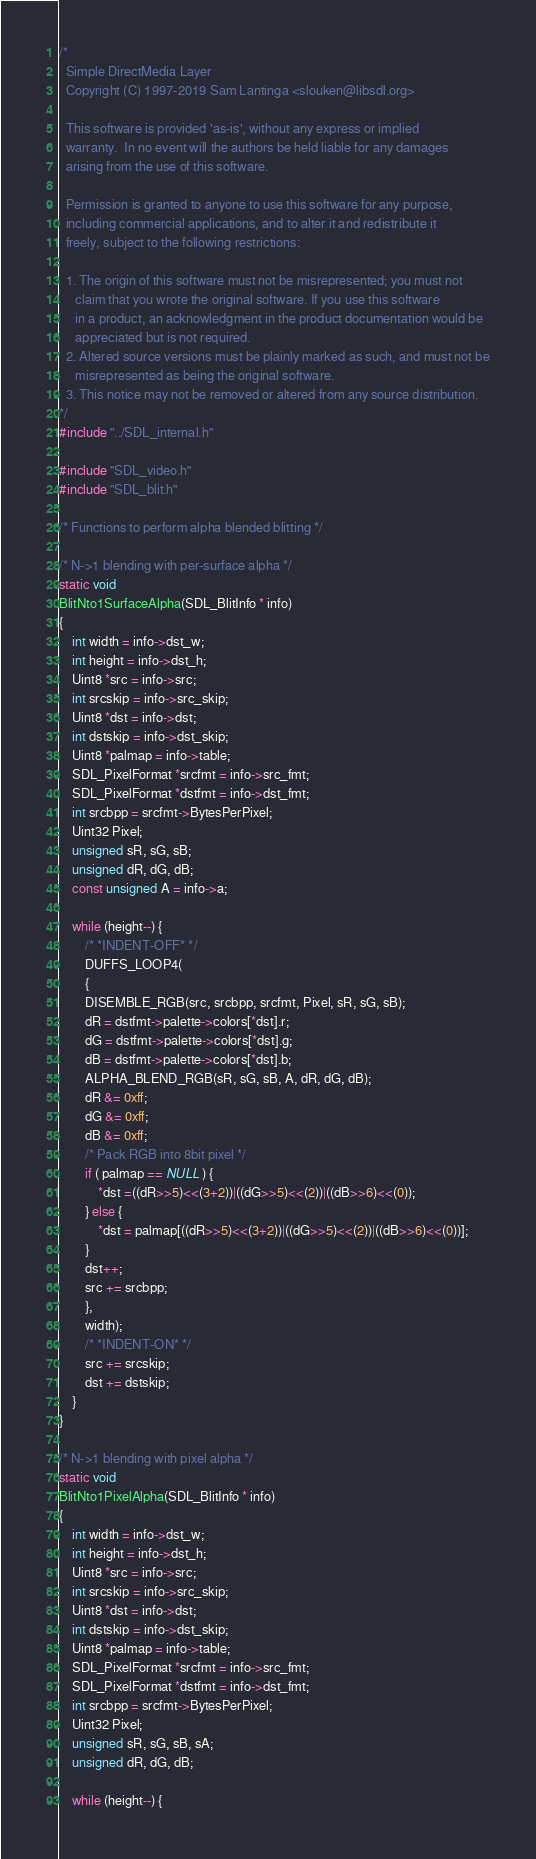Convert code to text. <code><loc_0><loc_0><loc_500><loc_500><_C_>/*
  Simple DirectMedia Layer
  Copyright (C) 1997-2019 Sam Lantinga <slouken@libsdl.org>

  This software is provided 'as-is', without any express or implied
  warranty.  In no event will the authors be held liable for any damages
  arising from the use of this software.

  Permission is granted to anyone to use this software for any purpose,
  including commercial applications, and to alter it and redistribute it
  freely, subject to the following restrictions:

  1. The origin of this software must not be misrepresented; you must not
     claim that you wrote the original software. If you use this software
     in a product, an acknowledgment in the product documentation would be
     appreciated but is not required.
  2. Altered source versions must be plainly marked as such, and must not be
     misrepresented as being the original software.
  3. This notice may not be removed or altered from any source distribution.
*/
#include "../SDL_internal.h"

#include "SDL_video.h"
#include "SDL_blit.h"

/* Functions to perform alpha blended blitting */

/* N->1 blending with per-surface alpha */
static void
BlitNto1SurfaceAlpha(SDL_BlitInfo * info)
{
    int width = info->dst_w;
    int height = info->dst_h;
    Uint8 *src = info->src;
    int srcskip = info->src_skip;
    Uint8 *dst = info->dst;
    int dstskip = info->dst_skip;
    Uint8 *palmap = info->table;
    SDL_PixelFormat *srcfmt = info->src_fmt;
    SDL_PixelFormat *dstfmt = info->dst_fmt;
    int srcbpp = srcfmt->BytesPerPixel;
    Uint32 Pixel;
    unsigned sR, sG, sB;
    unsigned dR, dG, dB;
    const unsigned A = info->a;

    while (height--) {
        /* *INDENT-OFF* */
        DUFFS_LOOP4(
        {
        DISEMBLE_RGB(src, srcbpp, srcfmt, Pixel, sR, sG, sB);
        dR = dstfmt->palette->colors[*dst].r;
        dG = dstfmt->palette->colors[*dst].g;
        dB = dstfmt->palette->colors[*dst].b;
        ALPHA_BLEND_RGB(sR, sG, sB, A, dR, dG, dB);
        dR &= 0xff;
        dG &= 0xff;
        dB &= 0xff;
        /* Pack RGB into 8bit pixel */
        if ( palmap == NULL ) {
            *dst =((dR>>5)<<(3+2))|((dG>>5)<<(2))|((dB>>6)<<(0));
        } else {
            *dst = palmap[((dR>>5)<<(3+2))|((dG>>5)<<(2))|((dB>>6)<<(0))];
        }
        dst++;
        src += srcbpp;
        },
        width);
        /* *INDENT-ON* */
        src += srcskip;
        dst += dstskip;
    }
}

/* N->1 blending with pixel alpha */
static void
BlitNto1PixelAlpha(SDL_BlitInfo * info)
{
    int width = info->dst_w;
    int height = info->dst_h;
    Uint8 *src = info->src;
    int srcskip = info->src_skip;
    Uint8 *dst = info->dst;
    int dstskip = info->dst_skip;
    Uint8 *palmap = info->table;
    SDL_PixelFormat *srcfmt = info->src_fmt;
    SDL_PixelFormat *dstfmt = info->dst_fmt;
    int srcbpp = srcfmt->BytesPerPixel;
    Uint32 Pixel;
    unsigned sR, sG, sB, sA;
    unsigned dR, dG, dB;

    while (height--) {</code> 